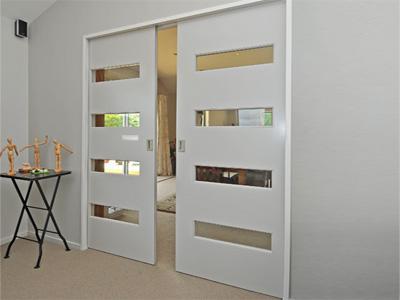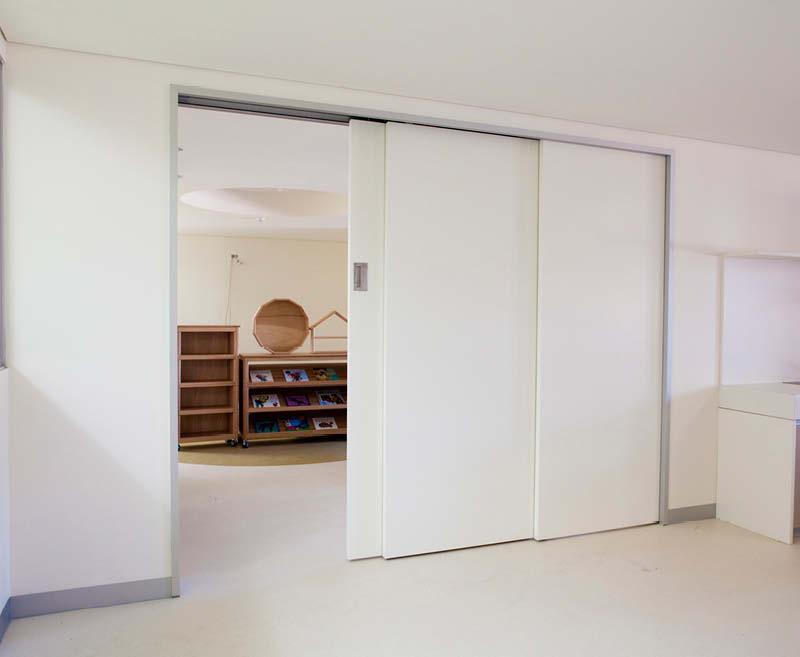The first image is the image on the left, the second image is the image on the right. Considering the images on both sides, is "In at  least one image there is a half open light brown wooden door that opens from the right." valid? Answer yes or no. No. The first image is the image on the left, the second image is the image on the right. Analyze the images presented: Is the assertion "An image shows solid white sliding doors that open into a room with wood furniture." valid? Answer yes or no. Yes. 